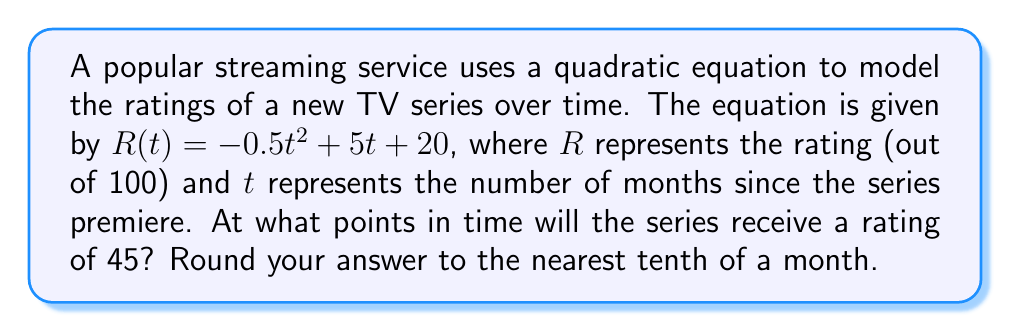Can you solve this math problem? To find the points in time when the series will receive a rating of 45, we need to solve the quadratic equation:

$$ -0.5t^2 + 5t + 20 = 45 $$

Let's solve this step-by-step:

1) First, subtract 45 from both sides to set the equation to zero:
   $$ -0.5t^2 + 5t - 25 = 0 $$

2) Multiply all terms by -2 to make the coefficient of $t^2$ a whole number:
   $$ t^2 - 10t + 50 = 0 $$

3) Now we can use the quadratic formula: $t = \frac{-b \pm \sqrt{b^2 - 4ac}}{2a}$
   Where $a = 1$, $b = -10$, and $c = 50$

4) Substituting these values:
   $$ t = \frac{10 \pm \sqrt{(-10)^2 - 4(1)(50)}}{2(1)} $$

5) Simplify under the square root:
   $$ t = \frac{10 \pm \sqrt{100 - 200}}{2} = \frac{10 \pm \sqrt{-100}}{2} $$

6) Simplify further:
   $$ t = \frac{10 \pm 10i}{2} $$

7) This gives us two complex roots:
   $$ t_1 = \frac{10 + 10i}{2} = 5 + 5i $$
   $$ t_2 = \frac{10 - 10i}{2} = 5 - 5i $$

However, since we're dealing with real-world time, we're only interested in the real part of these roots. Both roots have a real part of 5.
Answer: The series will receive a rating of 45 at 5.0 months after its premiere. 